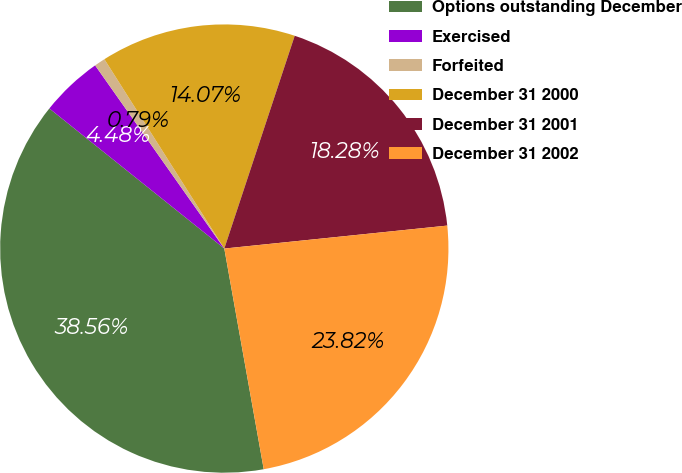<chart> <loc_0><loc_0><loc_500><loc_500><pie_chart><fcel>Options outstanding December<fcel>Exercised<fcel>Forfeited<fcel>December 31 2000<fcel>December 31 2001<fcel>December 31 2002<nl><fcel>38.56%<fcel>4.48%<fcel>0.79%<fcel>14.07%<fcel>18.28%<fcel>23.82%<nl></chart> 